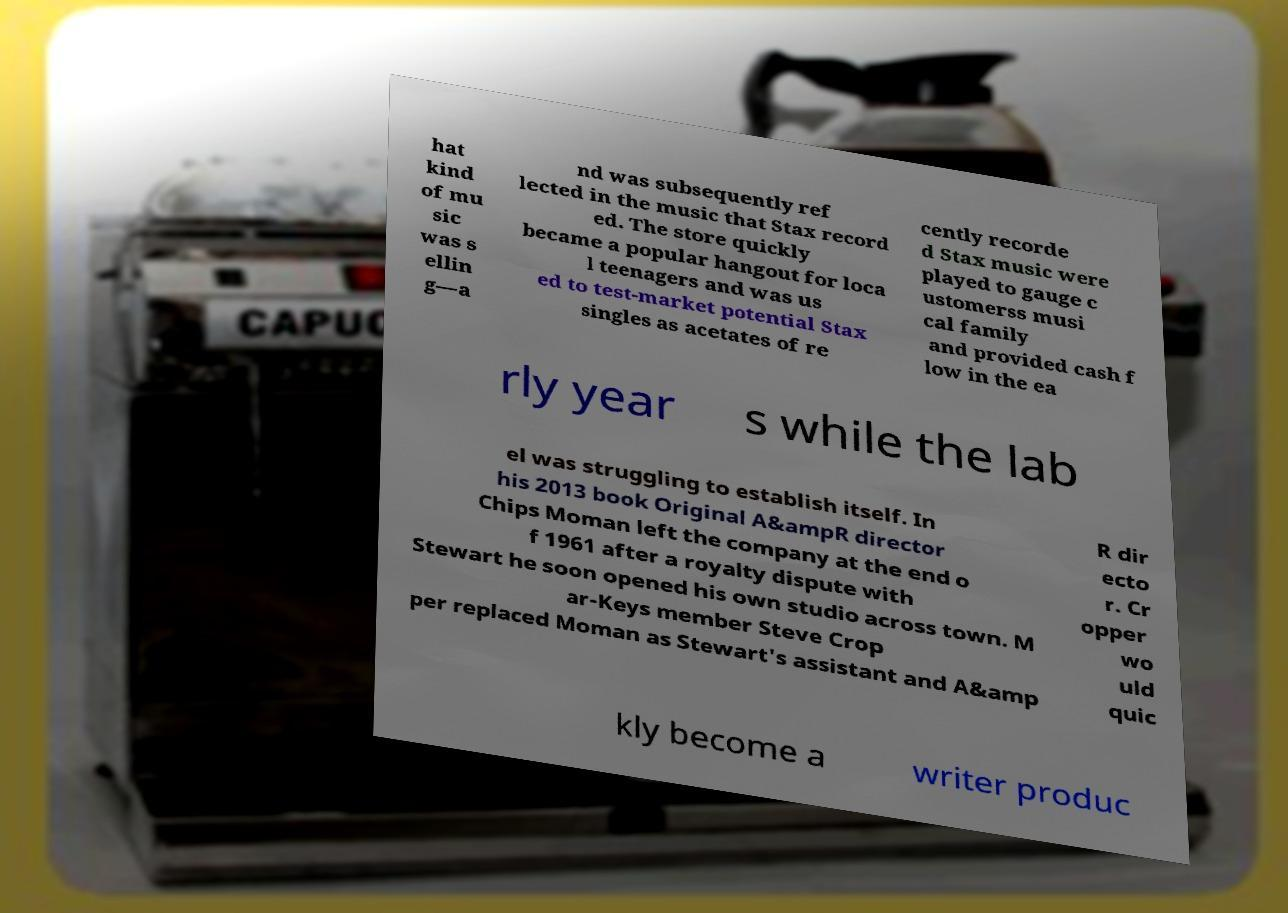For documentation purposes, I need the text within this image transcribed. Could you provide that? hat kind of mu sic was s ellin g—a nd was subsequently ref lected in the music that Stax record ed. The store quickly became a popular hangout for loca l teenagers and was us ed to test-market potential Stax singles as acetates of re cently recorde d Stax music were played to gauge c ustomerss musi cal family and provided cash f low in the ea rly year s while the lab el was struggling to establish itself. In his 2013 book Original A&ampR director Chips Moman left the company at the end o f 1961 after a royalty dispute with Stewart he soon opened his own studio across town. M ar-Keys member Steve Crop per replaced Moman as Stewart's assistant and A&amp R dir ecto r. Cr opper wo uld quic kly become a writer produc 